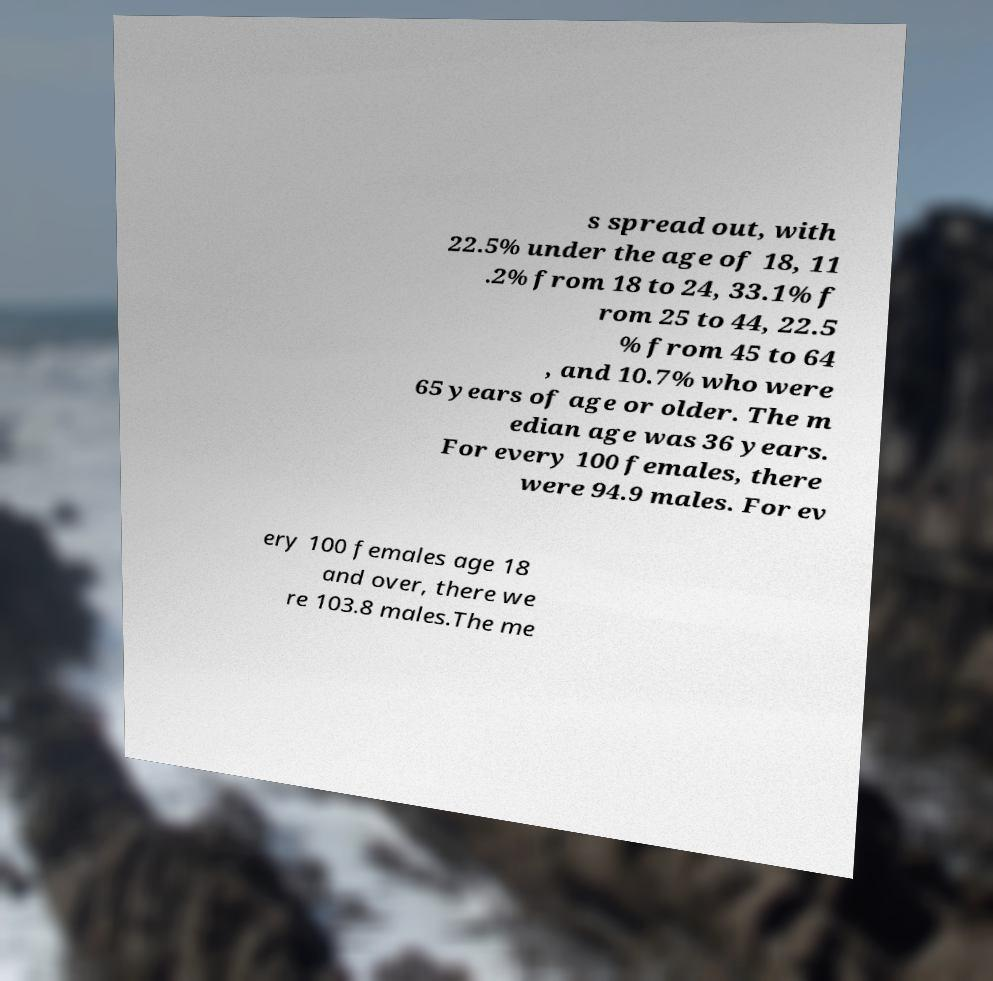Can you read and provide the text displayed in the image?This photo seems to have some interesting text. Can you extract and type it out for me? s spread out, with 22.5% under the age of 18, 11 .2% from 18 to 24, 33.1% f rom 25 to 44, 22.5 % from 45 to 64 , and 10.7% who were 65 years of age or older. The m edian age was 36 years. For every 100 females, there were 94.9 males. For ev ery 100 females age 18 and over, there we re 103.8 males.The me 